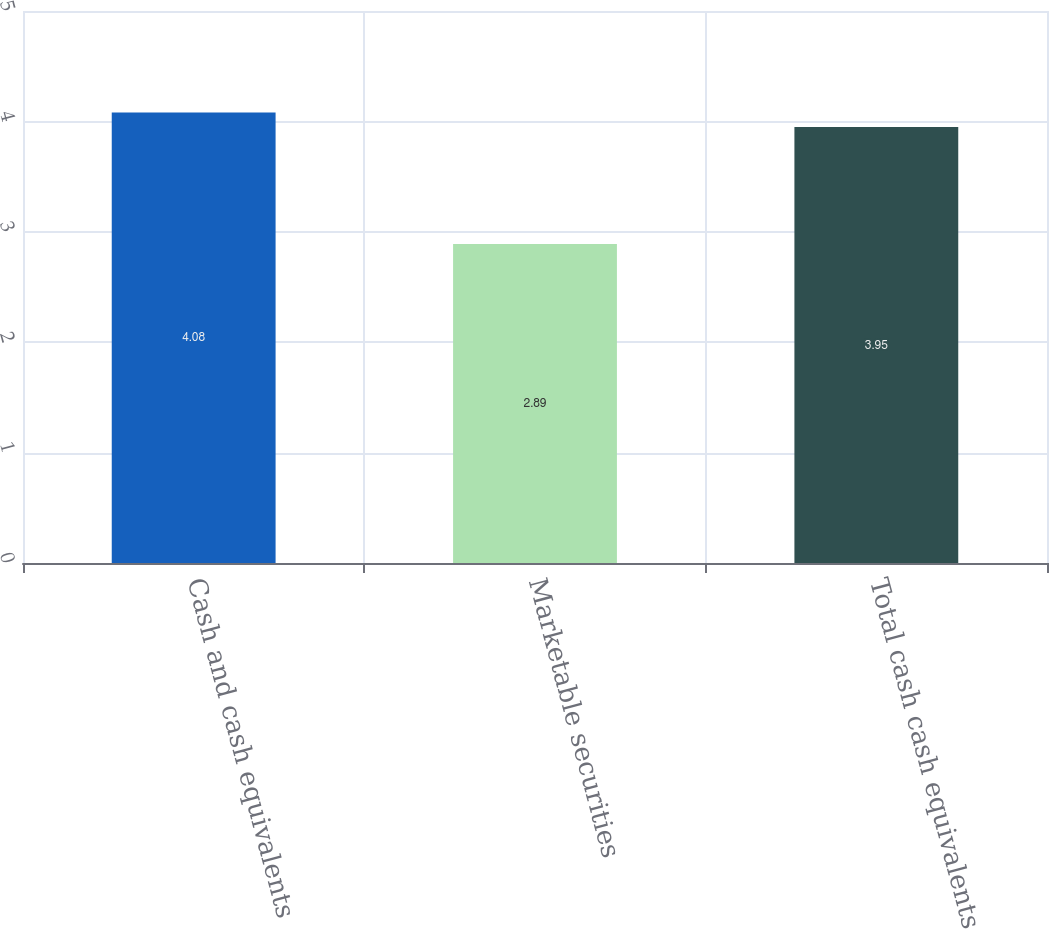Convert chart to OTSL. <chart><loc_0><loc_0><loc_500><loc_500><bar_chart><fcel>Cash and cash equivalents<fcel>Marketable securities<fcel>Total cash cash equivalents<nl><fcel>4.08<fcel>2.89<fcel>3.95<nl></chart> 